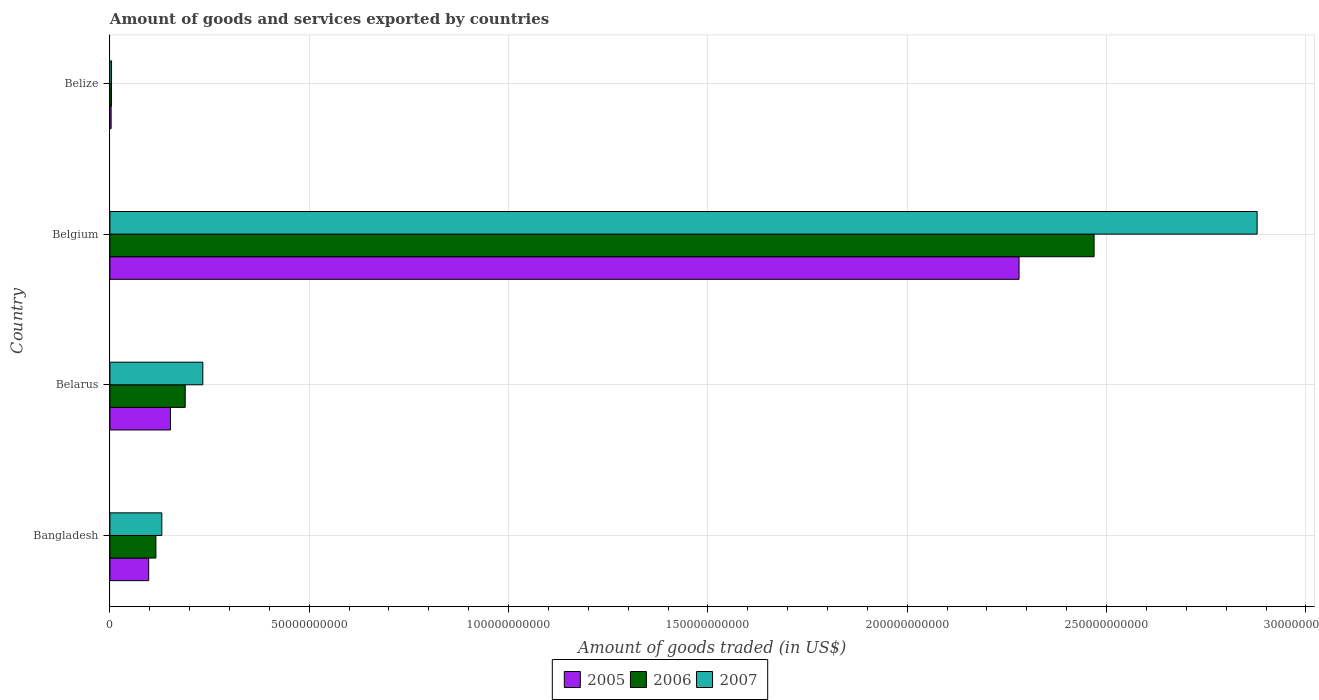How many groups of bars are there?
Make the answer very short. 4. Are the number of bars on each tick of the Y-axis equal?
Offer a very short reply. Yes. How many bars are there on the 1st tick from the bottom?
Give a very brief answer. 3. What is the label of the 1st group of bars from the top?
Offer a terse response. Belize. What is the total amount of goods and services exported in 2007 in Bangladesh?
Offer a very short reply. 1.30e+1. Across all countries, what is the maximum total amount of goods and services exported in 2007?
Offer a very short reply. 2.88e+11. Across all countries, what is the minimum total amount of goods and services exported in 2007?
Offer a very short reply. 4.16e+08. In which country was the total amount of goods and services exported in 2006 minimum?
Make the answer very short. Belize. What is the total total amount of goods and services exported in 2007 in the graph?
Keep it short and to the point. 3.25e+11. What is the difference between the total amount of goods and services exported in 2007 in Belarus and that in Belize?
Ensure brevity in your answer.  2.29e+1. What is the difference between the total amount of goods and services exported in 2007 in Bangladesh and the total amount of goods and services exported in 2006 in Belgium?
Provide a succinct answer. -2.34e+11. What is the average total amount of goods and services exported in 2005 per country?
Provide a short and direct response. 6.33e+1. What is the difference between the total amount of goods and services exported in 2006 and total amount of goods and services exported in 2007 in Belarus?
Make the answer very short. -4.41e+09. What is the ratio of the total amount of goods and services exported in 2007 in Belarus to that in Belize?
Offer a terse response. 56. Is the total amount of goods and services exported in 2007 in Bangladesh less than that in Belarus?
Your response must be concise. Yes. Is the difference between the total amount of goods and services exported in 2006 in Bangladesh and Belarus greater than the difference between the total amount of goods and services exported in 2007 in Bangladesh and Belarus?
Your answer should be compact. Yes. What is the difference between the highest and the second highest total amount of goods and services exported in 2006?
Your answer should be compact. 2.28e+11. What is the difference between the highest and the lowest total amount of goods and services exported in 2006?
Your answer should be very brief. 2.46e+11. In how many countries, is the total amount of goods and services exported in 2007 greater than the average total amount of goods and services exported in 2007 taken over all countries?
Provide a short and direct response. 1. Is the sum of the total amount of goods and services exported in 2007 in Belarus and Belgium greater than the maximum total amount of goods and services exported in 2006 across all countries?
Make the answer very short. Yes. Is it the case that in every country, the sum of the total amount of goods and services exported in 2007 and total amount of goods and services exported in 2006 is greater than the total amount of goods and services exported in 2005?
Provide a short and direct response. Yes. How many bars are there?
Ensure brevity in your answer.  12. Are all the bars in the graph horizontal?
Give a very brief answer. Yes. What is the difference between two consecutive major ticks on the X-axis?
Your answer should be compact. 5.00e+1. How many legend labels are there?
Provide a short and direct response. 3. What is the title of the graph?
Your response must be concise. Amount of goods and services exported by countries. What is the label or title of the X-axis?
Offer a terse response. Amount of goods traded (in US$). What is the Amount of goods traded (in US$) in 2005 in Bangladesh?
Provide a short and direct response. 9.73e+09. What is the Amount of goods traded (in US$) in 2006 in Bangladesh?
Offer a terse response. 1.15e+1. What is the Amount of goods traded (in US$) of 2007 in Bangladesh?
Keep it short and to the point. 1.30e+1. What is the Amount of goods traded (in US$) in 2005 in Belarus?
Offer a very short reply. 1.52e+1. What is the Amount of goods traded (in US$) in 2006 in Belarus?
Your response must be concise. 1.89e+1. What is the Amount of goods traded (in US$) of 2007 in Belarus?
Make the answer very short. 2.33e+1. What is the Amount of goods traded (in US$) in 2005 in Belgium?
Ensure brevity in your answer.  2.28e+11. What is the Amount of goods traded (in US$) of 2006 in Belgium?
Provide a short and direct response. 2.47e+11. What is the Amount of goods traded (in US$) of 2007 in Belgium?
Keep it short and to the point. 2.88e+11. What is the Amount of goods traded (in US$) in 2005 in Belize?
Provide a succinct answer. 3.08e+08. What is the Amount of goods traded (in US$) in 2006 in Belize?
Give a very brief answer. 4.09e+08. What is the Amount of goods traded (in US$) of 2007 in Belize?
Keep it short and to the point. 4.16e+08. Across all countries, what is the maximum Amount of goods traded (in US$) of 2005?
Your answer should be compact. 2.28e+11. Across all countries, what is the maximum Amount of goods traded (in US$) in 2006?
Your response must be concise. 2.47e+11. Across all countries, what is the maximum Amount of goods traded (in US$) in 2007?
Your response must be concise. 2.88e+11. Across all countries, what is the minimum Amount of goods traded (in US$) in 2005?
Offer a very short reply. 3.08e+08. Across all countries, what is the minimum Amount of goods traded (in US$) of 2006?
Keep it short and to the point. 4.09e+08. Across all countries, what is the minimum Amount of goods traded (in US$) of 2007?
Make the answer very short. 4.16e+08. What is the total Amount of goods traded (in US$) in 2005 in the graph?
Your response must be concise. 2.53e+11. What is the total Amount of goods traded (in US$) in 2006 in the graph?
Keep it short and to the point. 2.78e+11. What is the total Amount of goods traded (in US$) of 2007 in the graph?
Provide a short and direct response. 3.25e+11. What is the difference between the Amount of goods traded (in US$) in 2005 in Bangladesh and that in Belarus?
Offer a terse response. -5.46e+09. What is the difference between the Amount of goods traded (in US$) of 2006 in Bangladesh and that in Belarus?
Keep it short and to the point. -7.35e+09. What is the difference between the Amount of goods traded (in US$) in 2007 in Bangladesh and that in Belarus?
Make the answer very short. -1.03e+1. What is the difference between the Amount of goods traded (in US$) of 2005 in Bangladesh and that in Belgium?
Your response must be concise. -2.18e+11. What is the difference between the Amount of goods traded (in US$) in 2006 in Bangladesh and that in Belgium?
Your response must be concise. -2.35e+11. What is the difference between the Amount of goods traded (in US$) in 2007 in Bangladesh and that in Belgium?
Keep it short and to the point. -2.75e+11. What is the difference between the Amount of goods traded (in US$) of 2005 in Bangladesh and that in Belize?
Your response must be concise. 9.42e+09. What is the difference between the Amount of goods traded (in US$) in 2006 in Bangladesh and that in Belize?
Give a very brief answer. 1.11e+1. What is the difference between the Amount of goods traded (in US$) in 2007 in Bangladesh and that in Belize?
Offer a terse response. 1.26e+1. What is the difference between the Amount of goods traded (in US$) of 2005 in Belarus and that in Belgium?
Make the answer very short. -2.13e+11. What is the difference between the Amount of goods traded (in US$) of 2006 in Belarus and that in Belgium?
Provide a succinct answer. -2.28e+11. What is the difference between the Amount of goods traded (in US$) of 2007 in Belarus and that in Belgium?
Provide a short and direct response. -2.64e+11. What is the difference between the Amount of goods traded (in US$) of 2005 in Belarus and that in Belize?
Your answer should be compact. 1.49e+1. What is the difference between the Amount of goods traded (in US$) of 2006 in Belarus and that in Belize?
Make the answer very short. 1.85e+1. What is the difference between the Amount of goods traded (in US$) of 2007 in Belarus and that in Belize?
Ensure brevity in your answer.  2.29e+1. What is the difference between the Amount of goods traded (in US$) in 2005 in Belgium and that in Belize?
Your answer should be very brief. 2.28e+11. What is the difference between the Amount of goods traded (in US$) in 2006 in Belgium and that in Belize?
Offer a terse response. 2.46e+11. What is the difference between the Amount of goods traded (in US$) of 2007 in Belgium and that in Belize?
Offer a terse response. 2.87e+11. What is the difference between the Amount of goods traded (in US$) of 2005 in Bangladesh and the Amount of goods traded (in US$) of 2006 in Belarus?
Make the answer very short. -9.16e+09. What is the difference between the Amount of goods traded (in US$) of 2005 in Bangladesh and the Amount of goods traded (in US$) of 2007 in Belarus?
Provide a succinct answer. -1.36e+1. What is the difference between the Amount of goods traded (in US$) of 2006 in Bangladesh and the Amount of goods traded (in US$) of 2007 in Belarus?
Your response must be concise. -1.18e+1. What is the difference between the Amount of goods traded (in US$) in 2005 in Bangladesh and the Amount of goods traded (in US$) in 2006 in Belgium?
Give a very brief answer. -2.37e+11. What is the difference between the Amount of goods traded (in US$) in 2005 in Bangladesh and the Amount of goods traded (in US$) in 2007 in Belgium?
Provide a short and direct response. -2.78e+11. What is the difference between the Amount of goods traded (in US$) of 2006 in Bangladesh and the Amount of goods traded (in US$) of 2007 in Belgium?
Give a very brief answer. -2.76e+11. What is the difference between the Amount of goods traded (in US$) of 2005 in Bangladesh and the Amount of goods traded (in US$) of 2006 in Belize?
Make the answer very short. 9.32e+09. What is the difference between the Amount of goods traded (in US$) in 2005 in Bangladesh and the Amount of goods traded (in US$) in 2007 in Belize?
Offer a very short reply. 9.32e+09. What is the difference between the Amount of goods traded (in US$) in 2006 in Bangladesh and the Amount of goods traded (in US$) in 2007 in Belize?
Your answer should be very brief. 1.11e+1. What is the difference between the Amount of goods traded (in US$) of 2005 in Belarus and the Amount of goods traded (in US$) of 2006 in Belgium?
Keep it short and to the point. -2.32e+11. What is the difference between the Amount of goods traded (in US$) in 2005 in Belarus and the Amount of goods traded (in US$) in 2007 in Belgium?
Your response must be concise. -2.73e+11. What is the difference between the Amount of goods traded (in US$) in 2006 in Belarus and the Amount of goods traded (in US$) in 2007 in Belgium?
Keep it short and to the point. -2.69e+11. What is the difference between the Amount of goods traded (in US$) of 2005 in Belarus and the Amount of goods traded (in US$) of 2006 in Belize?
Your answer should be very brief. 1.48e+1. What is the difference between the Amount of goods traded (in US$) of 2005 in Belarus and the Amount of goods traded (in US$) of 2007 in Belize?
Keep it short and to the point. 1.48e+1. What is the difference between the Amount of goods traded (in US$) in 2006 in Belarus and the Amount of goods traded (in US$) in 2007 in Belize?
Keep it short and to the point. 1.85e+1. What is the difference between the Amount of goods traded (in US$) of 2005 in Belgium and the Amount of goods traded (in US$) of 2006 in Belize?
Provide a short and direct response. 2.28e+11. What is the difference between the Amount of goods traded (in US$) of 2005 in Belgium and the Amount of goods traded (in US$) of 2007 in Belize?
Ensure brevity in your answer.  2.28e+11. What is the difference between the Amount of goods traded (in US$) of 2006 in Belgium and the Amount of goods traded (in US$) of 2007 in Belize?
Your answer should be very brief. 2.46e+11. What is the average Amount of goods traded (in US$) in 2005 per country?
Offer a terse response. 6.33e+1. What is the average Amount of goods traded (in US$) of 2006 per country?
Make the answer very short. 6.94e+1. What is the average Amount of goods traded (in US$) in 2007 per country?
Give a very brief answer. 8.11e+1. What is the difference between the Amount of goods traded (in US$) of 2005 and Amount of goods traded (in US$) of 2006 in Bangladesh?
Your answer should be very brief. -1.81e+09. What is the difference between the Amount of goods traded (in US$) in 2005 and Amount of goods traded (in US$) in 2007 in Bangladesh?
Your response must be concise. -3.30e+09. What is the difference between the Amount of goods traded (in US$) in 2006 and Amount of goods traded (in US$) in 2007 in Bangladesh?
Offer a very short reply. -1.48e+09. What is the difference between the Amount of goods traded (in US$) of 2005 and Amount of goods traded (in US$) of 2006 in Belarus?
Your response must be concise. -3.70e+09. What is the difference between the Amount of goods traded (in US$) in 2005 and Amount of goods traded (in US$) in 2007 in Belarus?
Your answer should be compact. -8.12e+09. What is the difference between the Amount of goods traded (in US$) of 2006 and Amount of goods traded (in US$) of 2007 in Belarus?
Provide a succinct answer. -4.41e+09. What is the difference between the Amount of goods traded (in US$) of 2005 and Amount of goods traded (in US$) of 2006 in Belgium?
Give a very brief answer. -1.88e+1. What is the difference between the Amount of goods traded (in US$) of 2005 and Amount of goods traded (in US$) of 2007 in Belgium?
Your answer should be very brief. -5.97e+1. What is the difference between the Amount of goods traded (in US$) of 2006 and Amount of goods traded (in US$) of 2007 in Belgium?
Your answer should be very brief. -4.09e+1. What is the difference between the Amount of goods traded (in US$) in 2005 and Amount of goods traded (in US$) in 2006 in Belize?
Make the answer very short. -1.01e+08. What is the difference between the Amount of goods traded (in US$) of 2005 and Amount of goods traded (in US$) of 2007 in Belize?
Keep it short and to the point. -1.08e+08. What is the difference between the Amount of goods traded (in US$) in 2006 and Amount of goods traded (in US$) in 2007 in Belize?
Your response must be concise. -7.34e+06. What is the ratio of the Amount of goods traded (in US$) of 2005 in Bangladesh to that in Belarus?
Your answer should be very brief. 0.64. What is the ratio of the Amount of goods traded (in US$) of 2006 in Bangladesh to that in Belarus?
Your answer should be very brief. 0.61. What is the ratio of the Amount of goods traded (in US$) of 2007 in Bangladesh to that in Belarus?
Provide a short and direct response. 0.56. What is the ratio of the Amount of goods traded (in US$) of 2005 in Bangladesh to that in Belgium?
Your response must be concise. 0.04. What is the ratio of the Amount of goods traded (in US$) in 2006 in Bangladesh to that in Belgium?
Keep it short and to the point. 0.05. What is the ratio of the Amount of goods traded (in US$) in 2007 in Bangladesh to that in Belgium?
Give a very brief answer. 0.05. What is the ratio of the Amount of goods traded (in US$) in 2005 in Bangladesh to that in Belize?
Provide a succinct answer. 31.59. What is the ratio of the Amount of goods traded (in US$) in 2006 in Bangladesh to that in Belize?
Provide a succinct answer. 28.23. What is the ratio of the Amount of goods traded (in US$) in 2007 in Bangladesh to that in Belize?
Offer a very short reply. 31.3. What is the ratio of the Amount of goods traded (in US$) in 2005 in Belarus to that in Belgium?
Your answer should be compact. 0.07. What is the ratio of the Amount of goods traded (in US$) of 2006 in Belarus to that in Belgium?
Your answer should be very brief. 0.08. What is the ratio of the Amount of goods traded (in US$) in 2007 in Belarus to that in Belgium?
Ensure brevity in your answer.  0.08. What is the ratio of the Amount of goods traded (in US$) in 2005 in Belarus to that in Belize?
Provide a short and direct response. 49.32. What is the ratio of the Amount of goods traded (in US$) in 2006 in Belarus to that in Belize?
Ensure brevity in your answer.  46.21. What is the ratio of the Amount of goods traded (in US$) of 2007 in Belarus to that in Belize?
Your answer should be very brief. 56. What is the ratio of the Amount of goods traded (in US$) of 2005 in Belgium to that in Belize?
Give a very brief answer. 740.3. What is the ratio of the Amount of goods traded (in US$) of 2006 in Belgium to that in Belize?
Make the answer very short. 603.72. What is the ratio of the Amount of goods traded (in US$) of 2007 in Belgium to that in Belize?
Your answer should be very brief. 691.32. What is the difference between the highest and the second highest Amount of goods traded (in US$) in 2005?
Make the answer very short. 2.13e+11. What is the difference between the highest and the second highest Amount of goods traded (in US$) of 2006?
Your response must be concise. 2.28e+11. What is the difference between the highest and the second highest Amount of goods traded (in US$) in 2007?
Offer a very short reply. 2.64e+11. What is the difference between the highest and the lowest Amount of goods traded (in US$) of 2005?
Offer a terse response. 2.28e+11. What is the difference between the highest and the lowest Amount of goods traded (in US$) in 2006?
Your answer should be very brief. 2.46e+11. What is the difference between the highest and the lowest Amount of goods traded (in US$) in 2007?
Provide a succinct answer. 2.87e+11. 